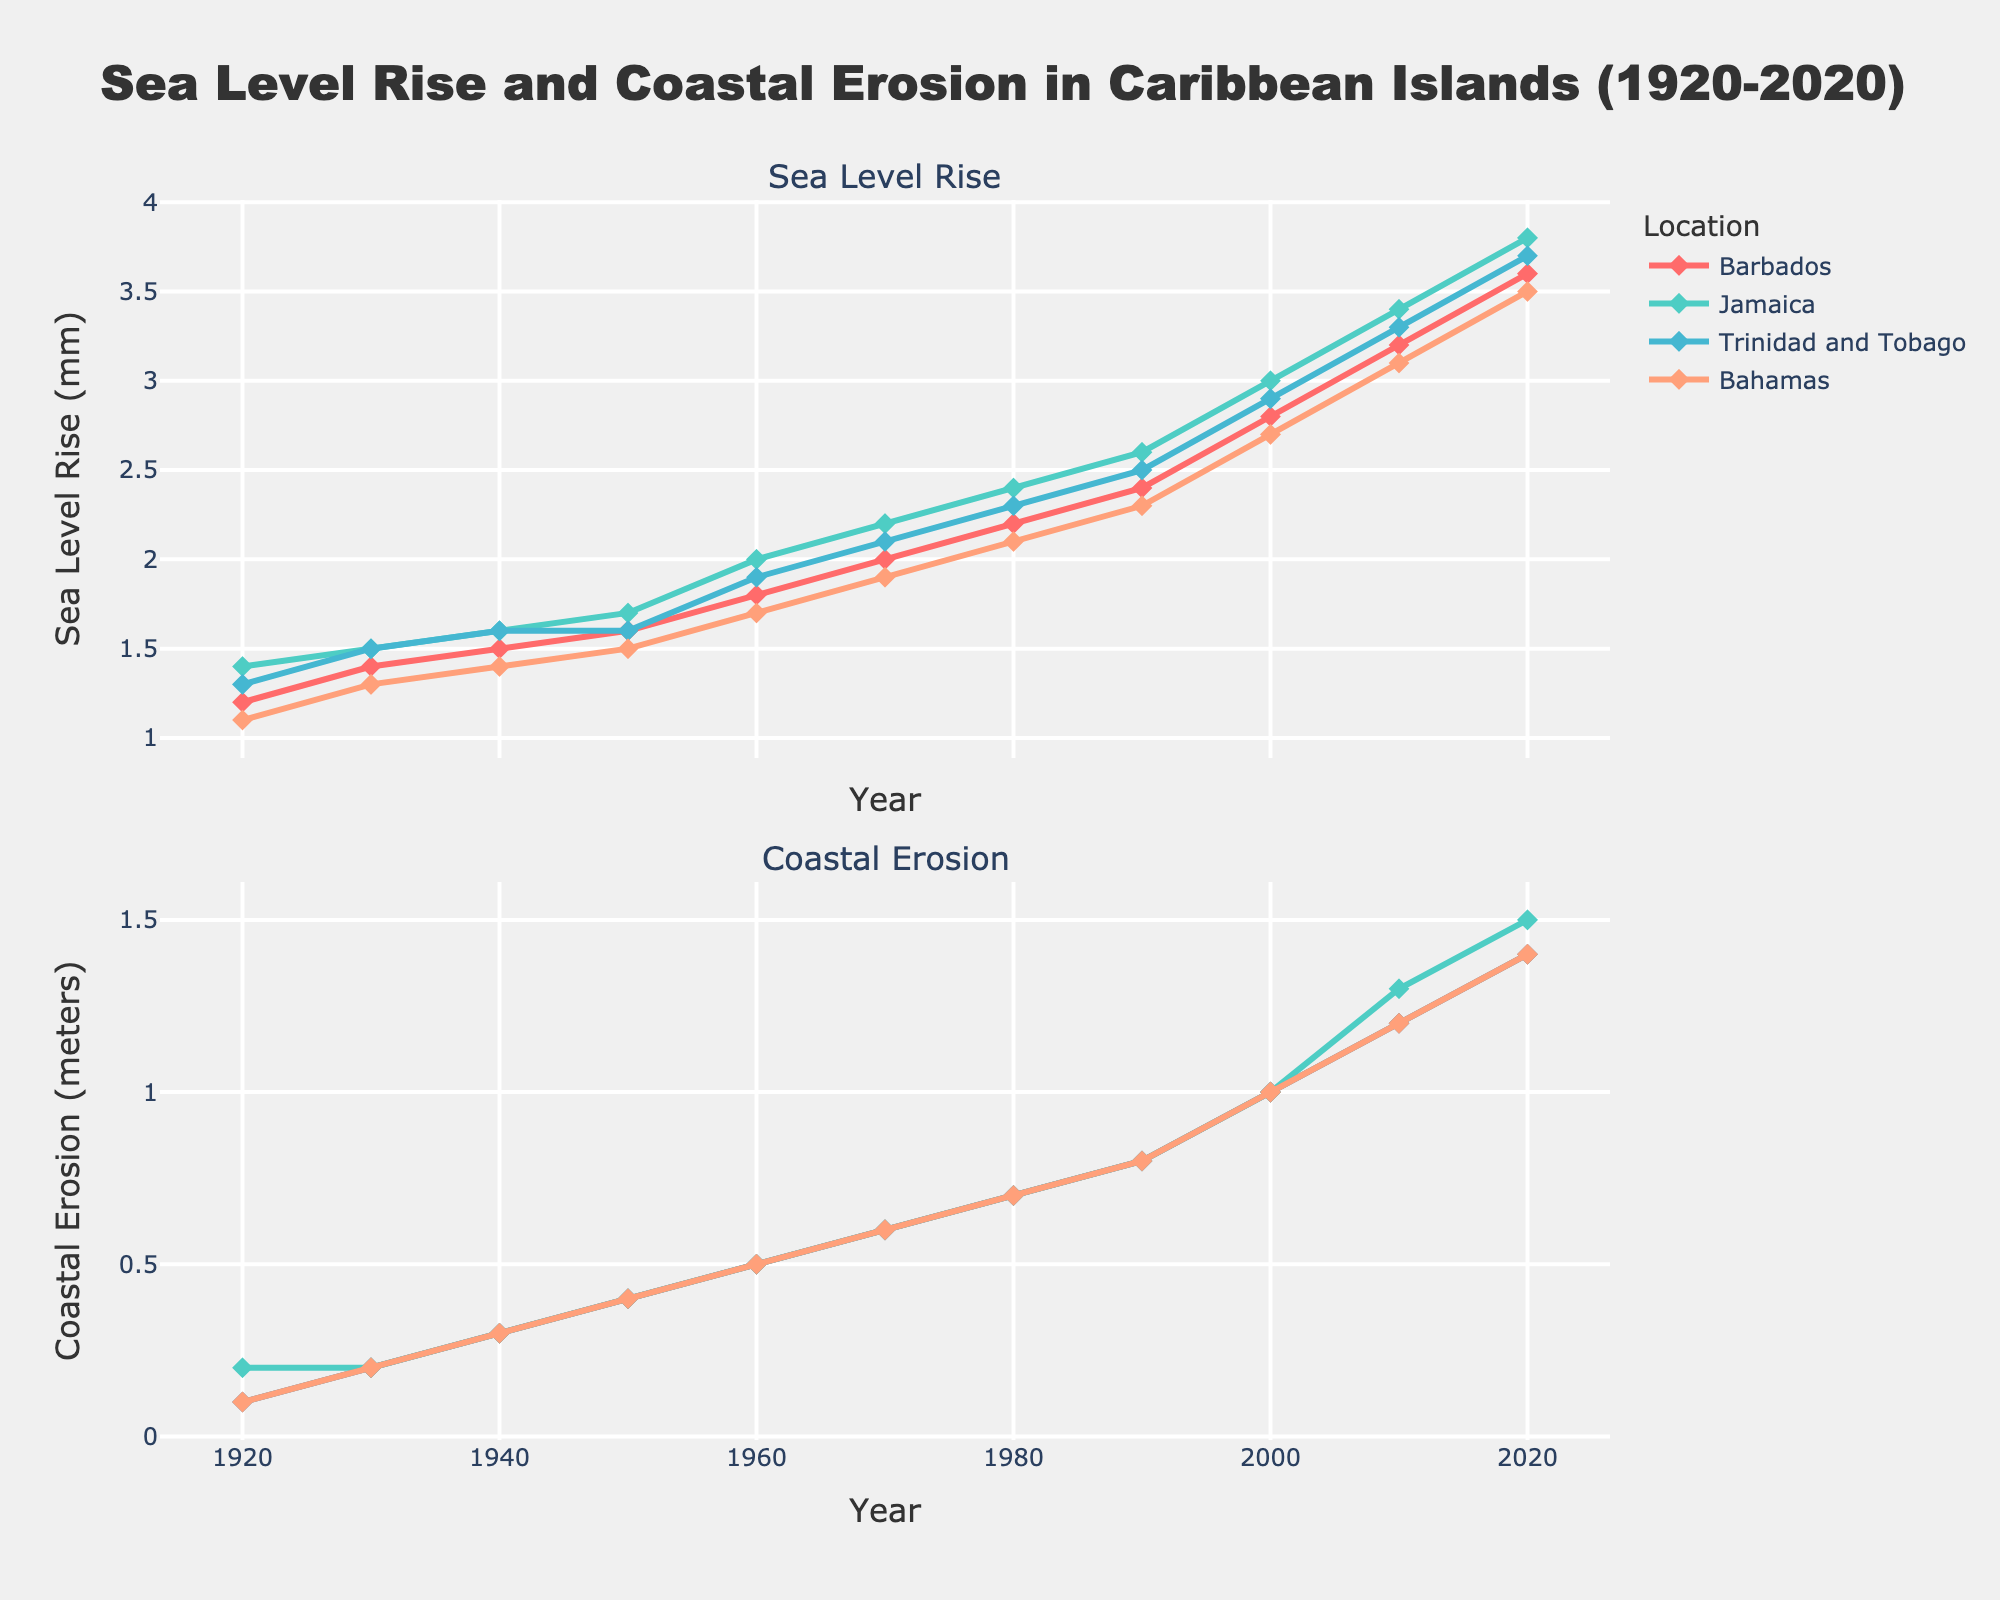What are the two main components measured in the figure? The figure measures "Sea Level Rise (mm)" and "Coastal Erosion (meters)" as stated in the subplot titles.
Answer: Sea Level Rise and Coastal Erosion Which Caribbean island shows the greatest sea level rise in 2020? According to the upper plot, Jamaica shows the highest sea level rise in 2020 at 3.8 mm.
Answer: Jamaica How has the coastal erosion trend in Barbados changed from 1920 to 2020? In the lower plot, the coastal erosion in Barbados has increased from 0.1 meters in 1920 to 1.4 meters in 2020.
Answer: Increased from 0.1 to 1.4 meters Which location had the smallest sea level rise in 1930? Referring to the upper plot, Bahamas had the smallest sea level rise in 1930 at 1.3 mm.
Answer: Bahamas How does Jamaica's coastal erosion in 1950 compare to that in 2020? Jamaica's coastal erosion increased from 0.4 meters in 1950 to 1.5 meters in 2020, indicating an increase of 1.1 meters over the period.
Answer: Increased by 1.1 meters Among the islands, which shows a higher average sea level rise over the century? Calculate the average sea level rise for each island and compare: Barbados (2.3 mm), Jamaica (2.47 mm), Trinidad and Tobago (2.33 mm), Bahamas (2.26 mm). Jamaica shows the highest average sea level rise.
Answer: Jamaica In which year did sea level rise in Trinidad and Tobago first exceed 2 mm? The upper plot shows that the sea level rise in Trinidad and Tobago first exceeded 2 mm in 1970.
Answer: 1970 What is the difference in sea level rise between Barbados and Bahamas in the year 2020? In 2020, Barbados had a sea level rise of 3.6 mm and Bahamas had 3.5 mm. The difference is 3.6 mm - 3.5 mm = 0.1 mm.
Answer: 0.1 mm Which island had the most pronounced increase in coastal erosion from 2000 to 2020? Compare the change in coastal erosion for each island between 2000 and 2020: Barbados (0.4 meters), Jamaica (0.5 meters), Trinidad and Tobago (0.4 meters), Bahamas (0.4 meters). Jamaica had the most pronounced increase of 0.5 meters.
Answer: Jamaica 